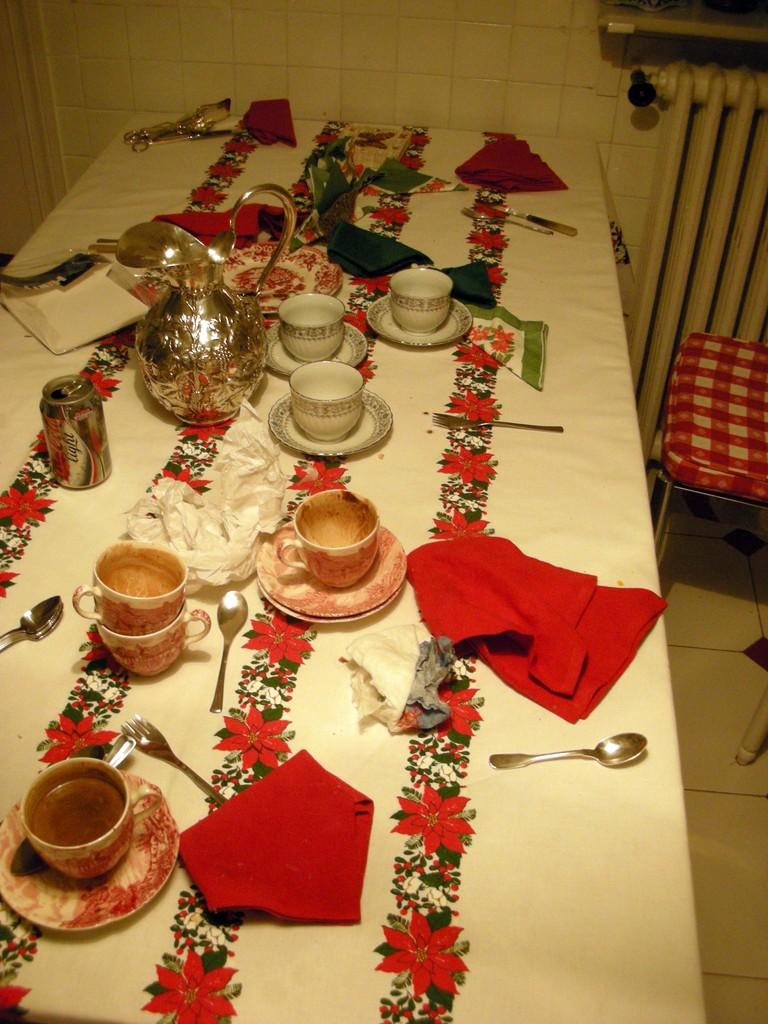What is on the table in the image? There is a cup, a saucer, a spoon, a tissue, a tin, and a jar on the table. What else can be seen in the image besides the table? There is a chair in the image. What might be used for stirring or eating in the image? The spoon on the table can be used for stirring or eating. What can be used for cleaning or wiping in the image? The tissue on the table can be used for cleaning or wiping. What type of owl is sitting on the chair in the image? There is no owl present in the image; it only features a chair and items on the table. 